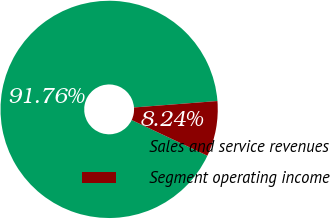<chart> <loc_0><loc_0><loc_500><loc_500><pie_chart><fcel>Sales and service revenues<fcel>Segment operating income<nl><fcel>91.76%<fcel>8.24%<nl></chart> 